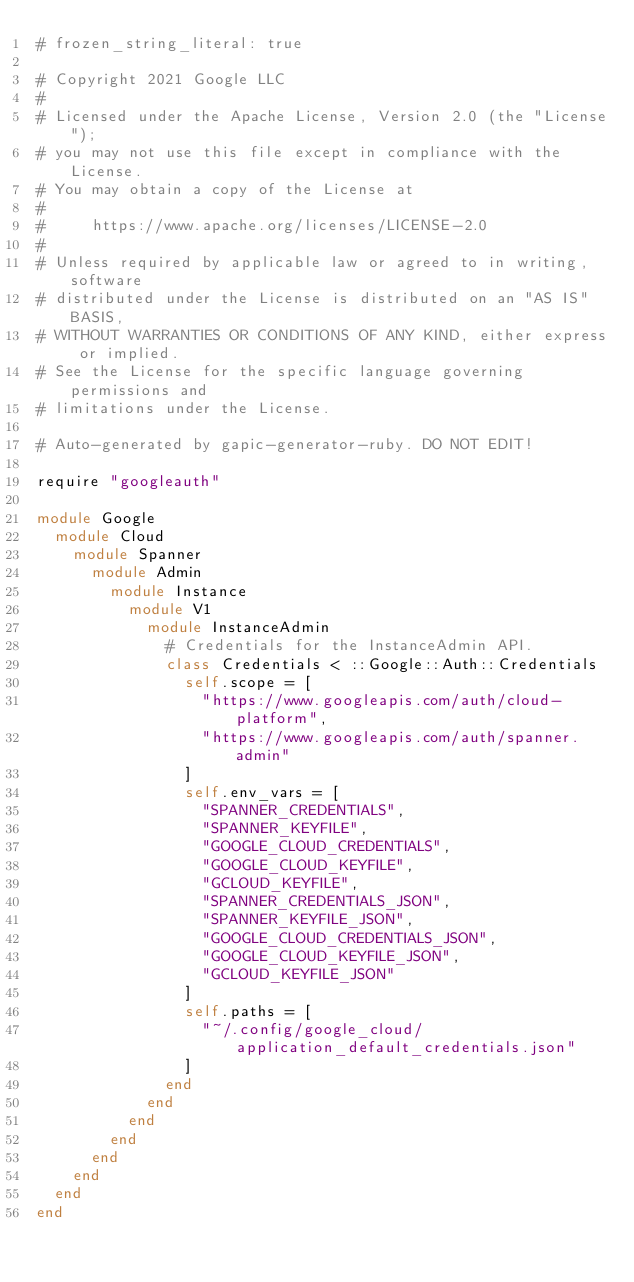<code> <loc_0><loc_0><loc_500><loc_500><_Ruby_># frozen_string_literal: true

# Copyright 2021 Google LLC
#
# Licensed under the Apache License, Version 2.0 (the "License");
# you may not use this file except in compliance with the License.
# You may obtain a copy of the License at
#
#     https://www.apache.org/licenses/LICENSE-2.0
#
# Unless required by applicable law or agreed to in writing, software
# distributed under the License is distributed on an "AS IS" BASIS,
# WITHOUT WARRANTIES OR CONDITIONS OF ANY KIND, either express or implied.
# See the License for the specific language governing permissions and
# limitations under the License.

# Auto-generated by gapic-generator-ruby. DO NOT EDIT!

require "googleauth"

module Google
  module Cloud
    module Spanner
      module Admin
        module Instance
          module V1
            module InstanceAdmin
              # Credentials for the InstanceAdmin API.
              class Credentials < ::Google::Auth::Credentials
                self.scope = [
                  "https://www.googleapis.com/auth/cloud-platform",
                  "https://www.googleapis.com/auth/spanner.admin"
                ]
                self.env_vars = [
                  "SPANNER_CREDENTIALS",
                  "SPANNER_KEYFILE",
                  "GOOGLE_CLOUD_CREDENTIALS",
                  "GOOGLE_CLOUD_KEYFILE",
                  "GCLOUD_KEYFILE",
                  "SPANNER_CREDENTIALS_JSON",
                  "SPANNER_KEYFILE_JSON",
                  "GOOGLE_CLOUD_CREDENTIALS_JSON",
                  "GOOGLE_CLOUD_KEYFILE_JSON",
                  "GCLOUD_KEYFILE_JSON"
                ]
                self.paths = [
                  "~/.config/google_cloud/application_default_credentials.json"
                ]
              end
            end
          end
        end
      end
    end
  end
end
</code> 